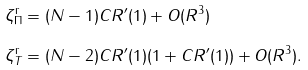<formula> <loc_0><loc_0><loc_500><loc_500>\zeta _ { \Pi } ^ { \text  r}&=(N-1)CR^{\prime}(1)+\mathcal{ }O(R^{3})\\  \zeta_{T}^{\text  r}&=(N-2)C R^{\prime}(1)(1+C R^{\prime}(1))+\mathcal{ }O(R^{3}).</formula> 